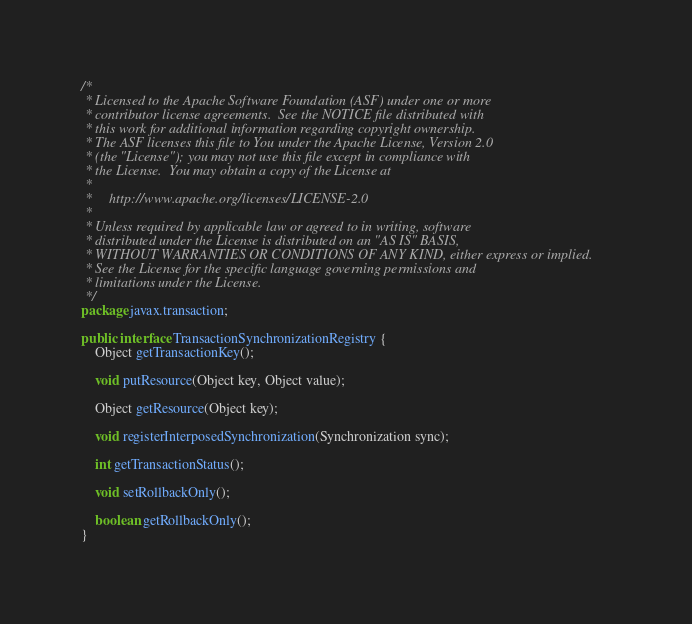<code> <loc_0><loc_0><loc_500><loc_500><_Java_>/*
 * Licensed to the Apache Software Foundation (ASF) under one or more
 * contributor license agreements.  See the NOTICE file distributed with
 * this work for additional information regarding copyright ownership.
 * The ASF licenses this file to You under the Apache License, Version 2.0
 * (the "License"); you may not use this file except in compliance with
 * the License.  You may obtain a copy of the License at
 *
 *     http://www.apache.org/licenses/LICENSE-2.0
 *
 * Unless required by applicable law or agreed to in writing, software
 * distributed under the License is distributed on an "AS IS" BASIS,
 * WITHOUT WARRANTIES OR CONDITIONS OF ANY KIND, either express or implied.
 * See the License for the specific language governing permissions and
 * limitations under the License.
 */
package javax.transaction;

public interface TransactionSynchronizationRegistry {
    Object getTransactionKey();

    void putResource(Object key, Object value);

    Object getResource(Object key);

    void registerInterposedSynchronization(Synchronization sync);

    int getTransactionStatus();

    void setRollbackOnly();

    boolean getRollbackOnly();
}
</code> 